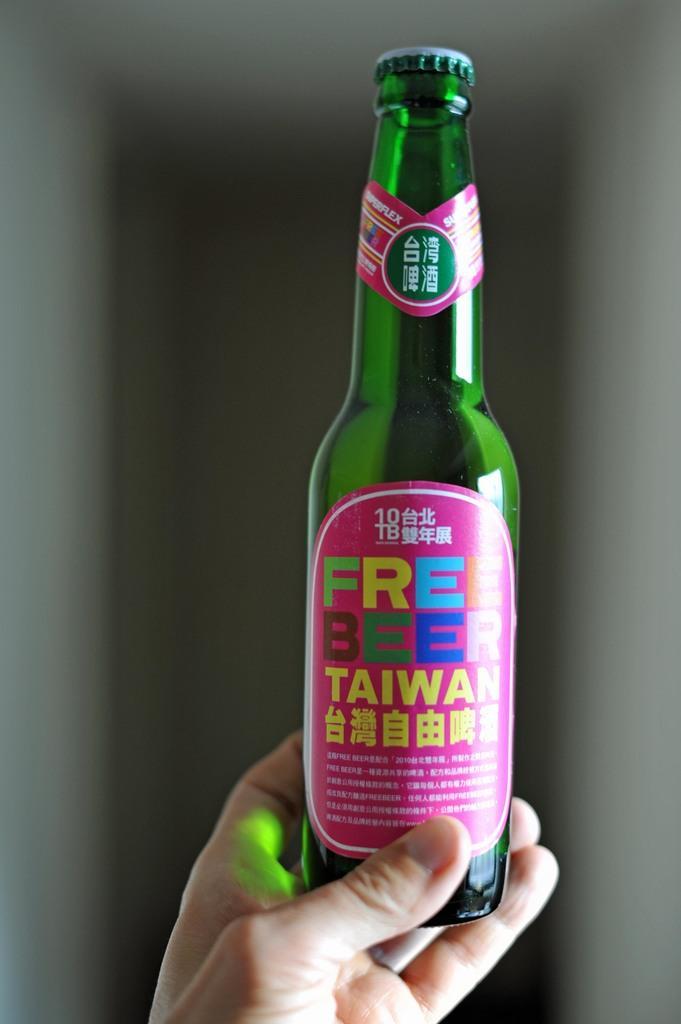In one or two sentences, can you explain what this image depicts? In the image there is a person holding a bottle on which it is labelled as 'FREE BEER' in background there is a white color wall. 